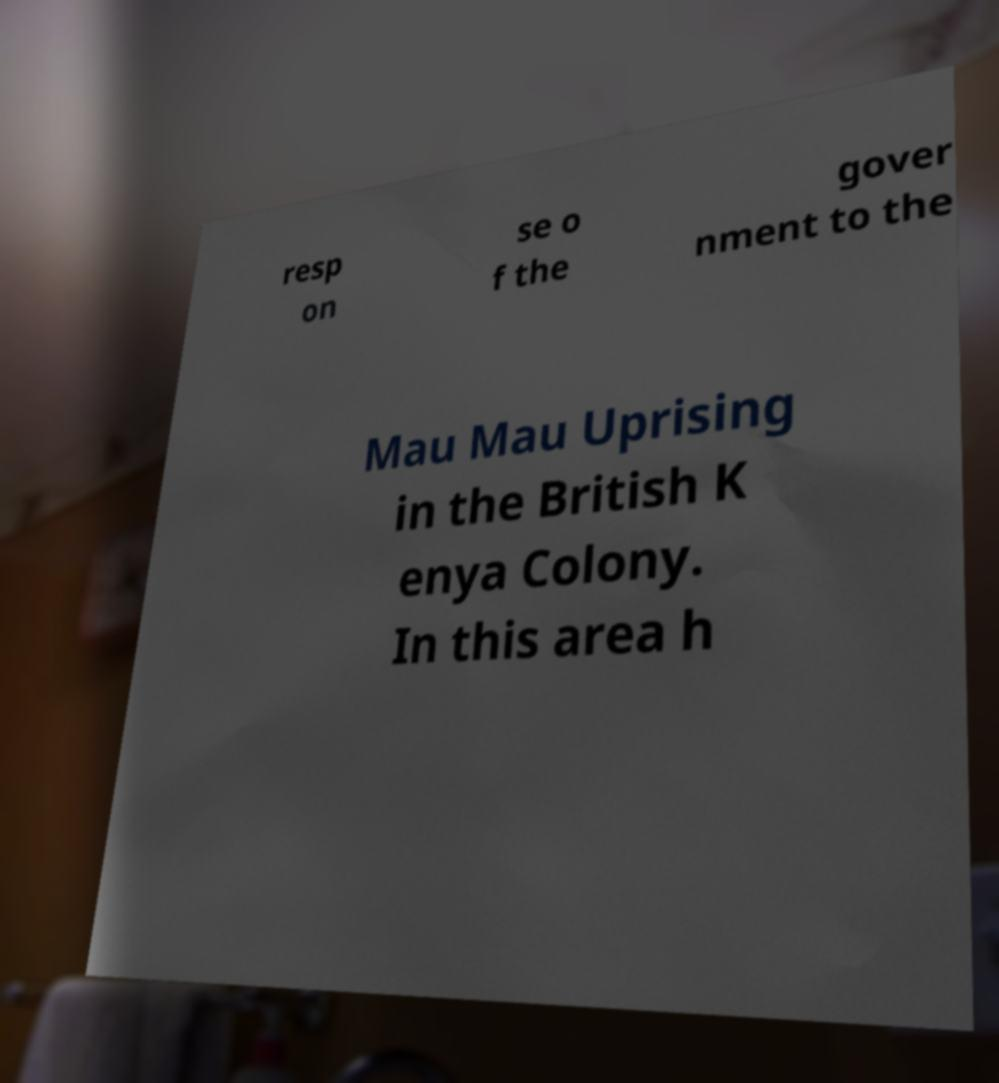I need the written content from this picture converted into text. Can you do that? resp on se o f the gover nment to the Mau Mau Uprising in the British K enya Colony. In this area h 